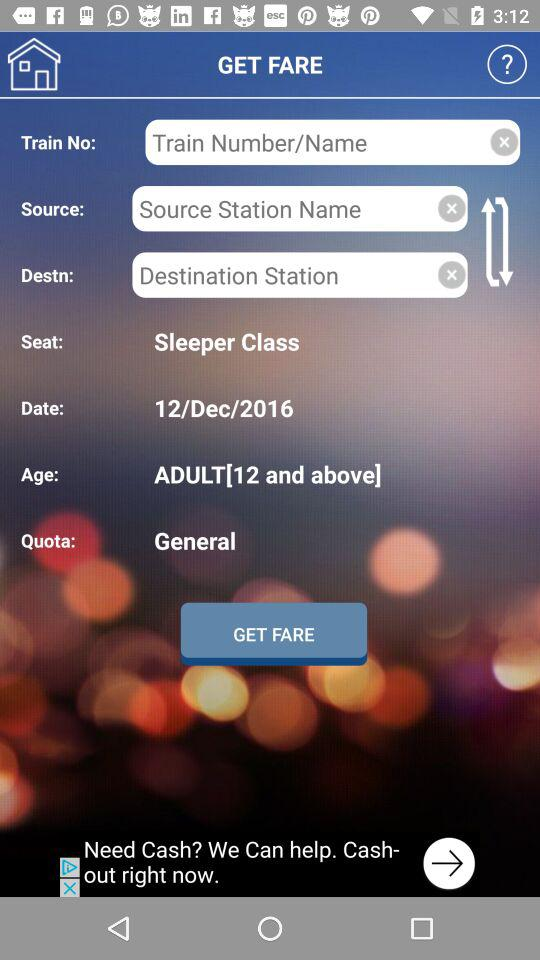In which category do the people above the age of 12 fall? The people above the age of 12 fall in the "ADULT" category. 